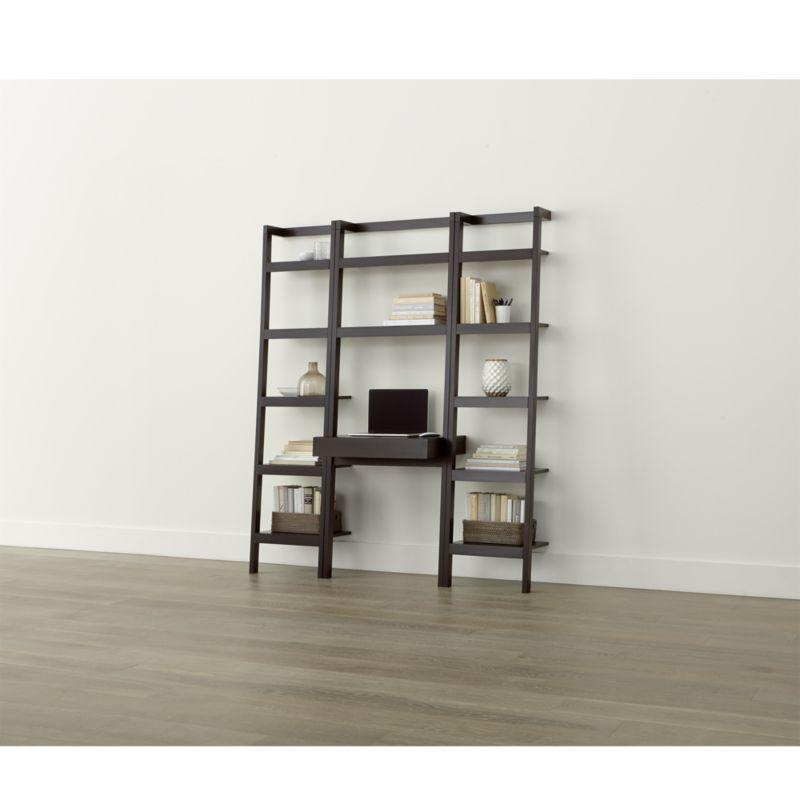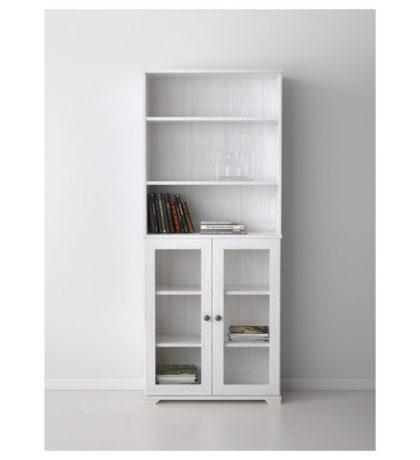The first image is the image on the left, the second image is the image on the right. Given the left and right images, does the statement "The shelf unit in the left image can stand on its own." hold true? Answer yes or no. No. 